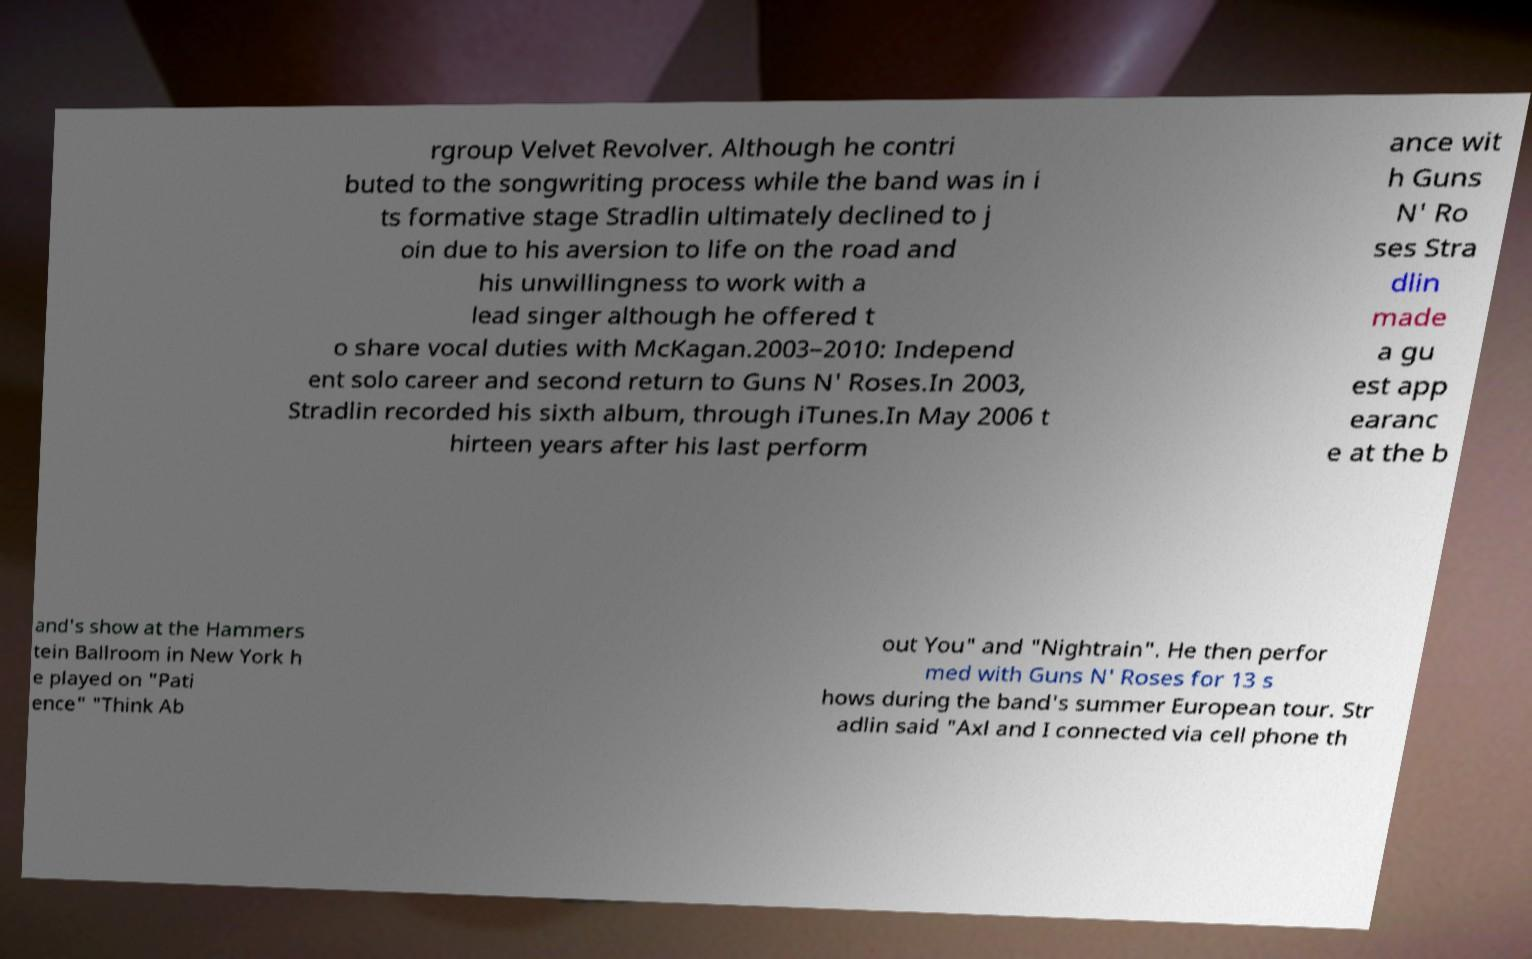Could you extract and type out the text from this image? rgroup Velvet Revolver. Although he contri buted to the songwriting process while the band was in i ts formative stage Stradlin ultimately declined to j oin due to his aversion to life on the road and his unwillingness to work with a lead singer although he offered t o share vocal duties with McKagan.2003–2010: Independ ent solo career and second return to Guns N' Roses.In 2003, Stradlin recorded his sixth album, through iTunes.In May 2006 t hirteen years after his last perform ance wit h Guns N' Ro ses Stra dlin made a gu est app earanc e at the b and's show at the Hammers tein Ballroom in New York h e played on "Pati ence" "Think Ab out You" and "Nightrain". He then perfor med with Guns N' Roses for 13 s hows during the band's summer European tour. Str adlin said "Axl and I connected via cell phone th 